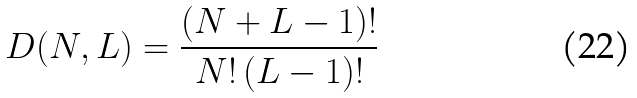Convert formula to latex. <formula><loc_0><loc_0><loc_500><loc_500>D ( N , L ) = \frac { ( N + L - 1 ) ! } { N ! \, ( L - 1 ) ! }</formula> 